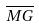Convert formula to latex. <formula><loc_0><loc_0><loc_500><loc_500>\overline { M G }</formula> 